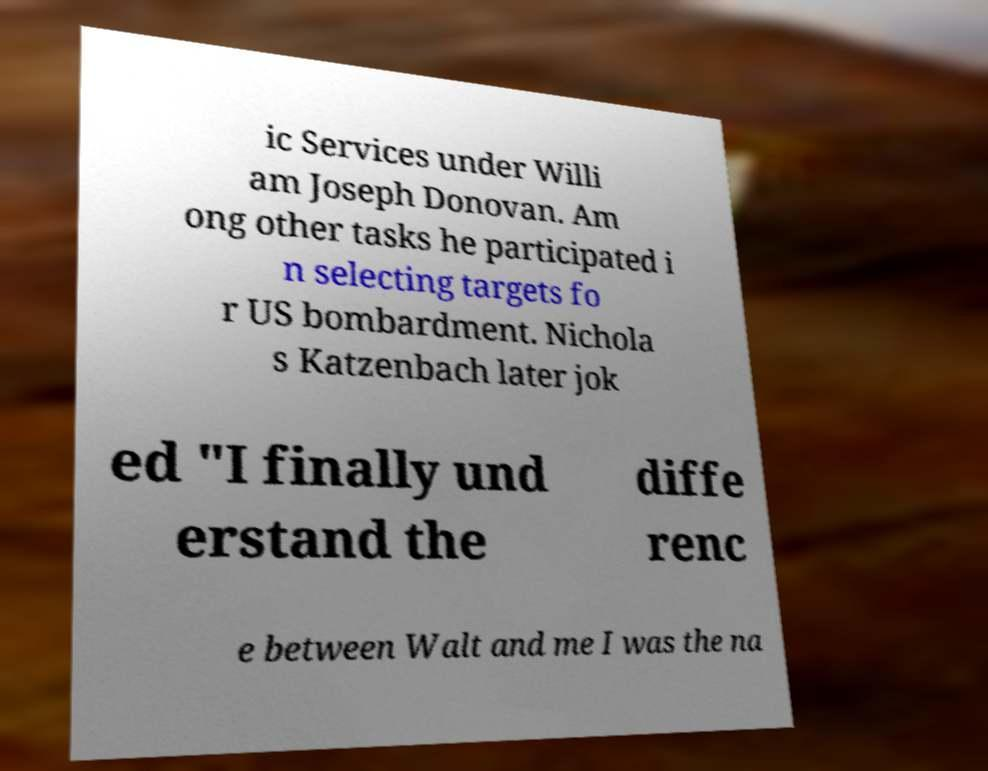I need the written content from this picture converted into text. Can you do that? ic Services under Willi am Joseph Donovan. Am ong other tasks he participated i n selecting targets fo r US bombardment. Nichola s Katzenbach later jok ed "I finally und erstand the diffe renc e between Walt and me I was the na 